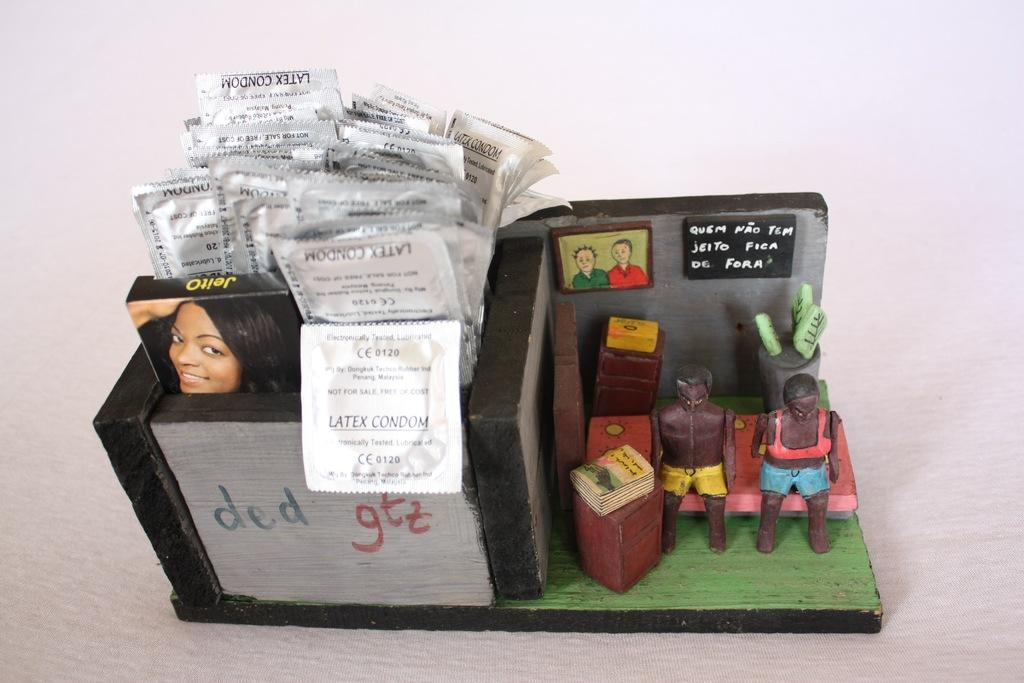What is the main object in the image? There is a box in the image. What else can be seen in the image besides the box? There are packets, boards, and toys in the image. What is written or depicted on the boards? Text is present on the boards. What shape is the debt taking in the image? There is no mention of debt in the image, so it cannot be determined what shape it might be taking. 